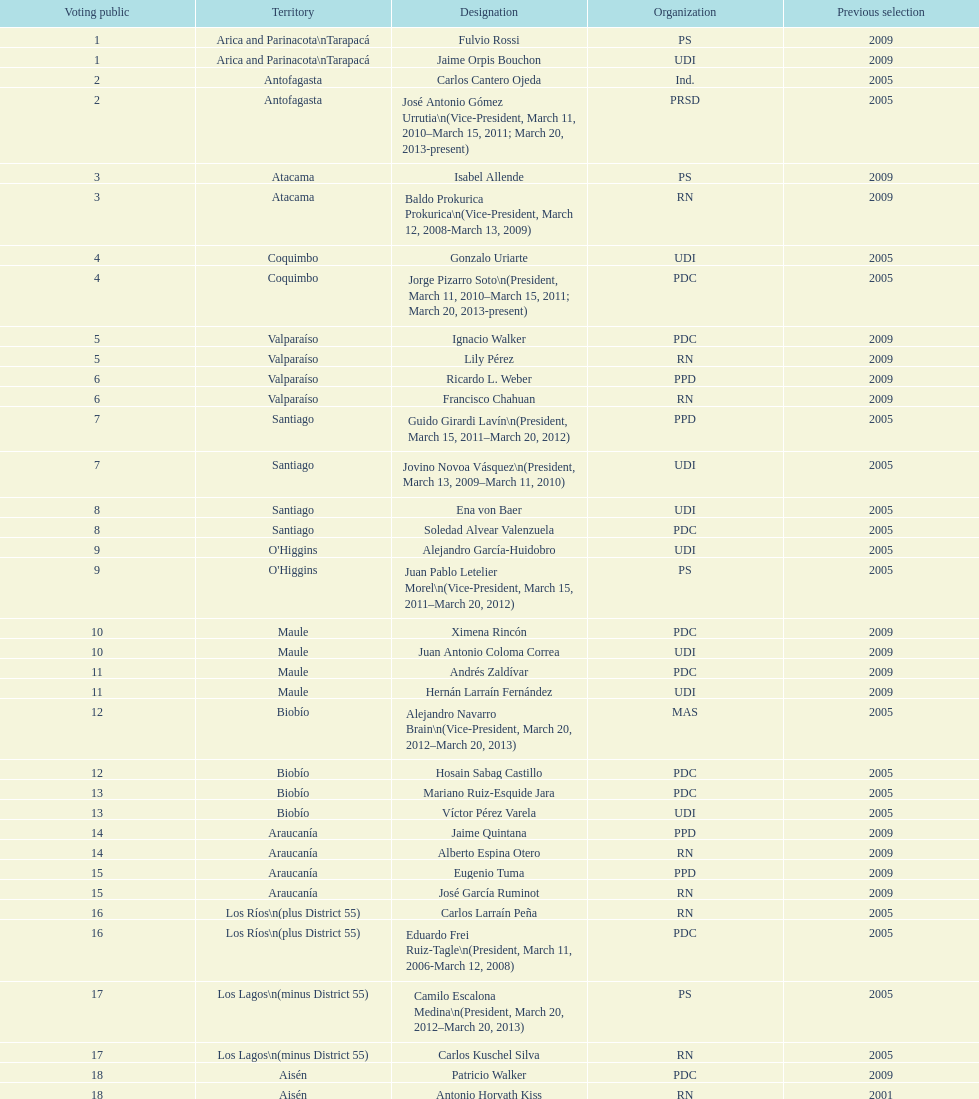Which region is listed below atacama? Coquimbo. Could you parse the entire table as a dict? {'header': ['Voting public', 'Territory', 'Designation', 'Organization', 'Previous selection'], 'rows': [['1', 'Arica and Parinacota\\nTarapacá', 'Fulvio Rossi', 'PS', '2009'], ['1', 'Arica and Parinacota\\nTarapacá', 'Jaime Orpis Bouchon', 'UDI', '2009'], ['2', 'Antofagasta', 'Carlos Cantero Ojeda', 'Ind.', '2005'], ['2', 'Antofagasta', 'José Antonio Gómez Urrutia\\n(Vice-President, March 11, 2010–March 15, 2011; March 20, 2013-present)', 'PRSD', '2005'], ['3', 'Atacama', 'Isabel Allende', 'PS', '2009'], ['3', 'Atacama', 'Baldo Prokurica Prokurica\\n(Vice-President, March 12, 2008-March 13, 2009)', 'RN', '2009'], ['4', 'Coquimbo', 'Gonzalo Uriarte', 'UDI', '2005'], ['4', 'Coquimbo', 'Jorge Pizarro Soto\\n(President, March 11, 2010–March 15, 2011; March 20, 2013-present)', 'PDC', '2005'], ['5', 'Valparaíso', 'Ignacio Walker', 'PDC', '2009'], ['5', 'Valparaíso', 'Lily Pérez', 'RN', '2009'], ['6', 'Valparaíso', 'Ricardo L. Weber', 'PPD', '2009'], ['6', 'Valparaíso', 'Francisco Chahuan', 'RN', '2009'], ['7', 'Santiago', 'Guido Girardi Lavín\\n(President, March 15, 2011–March 20, 2012)', 'PPD', '2005'], ['7', 'Santiago', 'Jovino Novoa Vásquez\\n(President, March 13, 2009–March 11, 2010)', 'UDI', '2005'], ['8', 'Santiago', 'Ena von Baer', 'UDI', '2005'], ['8', 'Santiago', 'Soledad Alvear Valenzuela', 'PDC', '2005'], ['9', "O'Higgins", 'Alejandro García-Huidobro', 'UDI', '2005'], ['9', "O'Higgins", 'Juan Pablo Letelier Morel\\n(Vice-President, March 15, 2011–March 20, 2012)', 'PS', '2005'], ['10', 'Maule', 'Ximena Rincón', 'PDC', '2009'], ['10', 'Maule', 'Juan Antonio Coloma Correa', 'UDI', '2009'], ['11', 'Maule', 'Andrés Zaldívar', 'PDC', '2009'], ['11', 'Maule', 'Hernán Larraín Fernández', 'UDI', '2009'], ['12', 'Biobío', 'Alejandro Navarro Brain\\n(Vice-President, March 20, 2012–March 20, 2013)', 'MAS', '2005'], ['12', 'Biobío', 'Hosain Sabag Castillo', 'PDC', '2005'], ['13', 'Biobío', 'Mariano Ruiz-Esquide Jara', 'PDC', '2005'], ['13', 'Biobío', 'Víctor Pérez Varela', 'UDI', '2005'], ['14', 'Araucanía', 'Jaime Quintana', 'PPD', '2009'], ['14', 'Araucanía', 'Alberto Espina Otero', 'RN', '2009'], ['15', 'Araucanía', 'Eugenio Tuma', 'PPD', '2009'], ['15', 'Araucanía', 'José García Ruminot', 'RN', '2009'], ['16', 'Los Ríos\\n(plus District 55)', 'Carlos Larraín Peña', 'RN', '2005'], ['16', 'Los Ríos\\n(plus District 55)', 'Eduardo Frei Ruiz-Tagle\\n(President, March 11, 2006-March 12, 2008)', 'PDC', '2005'], ['17', 'Los Lagos\\n(minus District 55)', 'Camilo Escalona Medina\\n(President, March 20, 2012–March 20, 2013)', 'PS', '2005'], ['17', 'Los Lagos\\n(minus District 55)', 'Carlos Kuschel Silva', 'RN', '2005'], ['18', 'Aisén', 'Patricio Walker', 'PDC', '2009'], ['18', 'Aisén', 'Antonio Horvath Kiss', 'RN', '2001'], ['19', 'Magallanes', 'Carlos Bianchi Chelech\\n(Vice-President, March 13, 2009–March 11, 2010)', 'Ind.', '2005'], ['19', 'Magallanes', 'Pedro Muñoz Aburto', 'PS', '2005']]} 